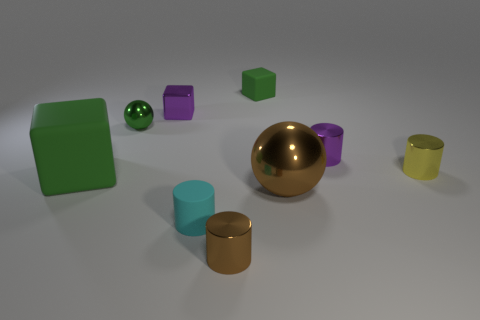What number of objects are rubber objects that are in front of the yellow object or small green things in front of the small metal block?
Give a very brief answer. 3. There is a large object to the right of the cube in front of the yellow thing; what shape is it?
Give a very brief answer. Sphere. Are there any tiny green things made of the same material as the big block?
Provide a short and direct response. Yes. There is a tiny metallic thing that is the same shape as the large shiny thing; what is its color?
Offer a very short reply. Green. Is the number of tiny metallic spheres that are on the right side of the big rubber cube less than the number of small metal cubes that are in front of the yellow shiny object?
Provide a succinct answer. No. How many other objects are the same shape as the small cyan object?
Make the answer very short. 3. Is the number of tiny cylinders that are behind the tiny green sphere less than the number of balls?
Provide a succinct answer. Yes. What is the material of the cube that is in front of the yellow metallic cylinder?
Your answer should be compact. Rubber. What number of other things are the same size as the yellow cylinder?
Give a very brief answer. 6. Are there fewer big brown objects than large matte cylinders?
Offer a terse response. No. 